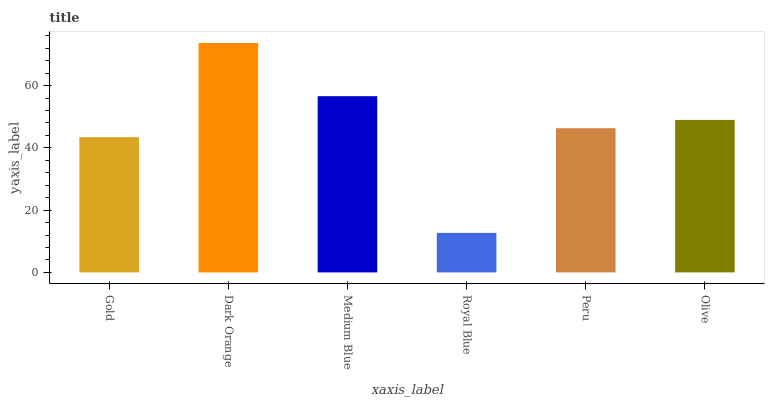Is Royal Blue the minimum?
Answer yes or no. Yes. Is Dark Orange the maximum?
Answer yes or no. Yes. Is Medium Blue the minimum?
Answer yes or no. No. Is Medium Blue the maximum?
Answer yes or no. No. Is Dark Orange greater than Medium Blue?
Answer yes or no. Yes. Is Medium Blue less than Dark Orange?
Answer yes or no. Yes. Is Medium Blue greater than Dark Orange?
Answer yes or no. No. Is Dark Orange less than Medium Blue?
Answer yes or no. No. Is Olive the high median?
Answer yes or no. Yes. Is Peru the low median?
Answer yes or no. Yes. Is Gold the high median?
Answer yes or no. No. Is Royal Blue the low median?
Answer yes or no. No. 